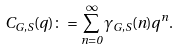<formula> <loc_0><loc_0><loc_500><loc_500>C _ { G , S } ( q ) \colon = \sum _ { n = 0 } ^ { \infty } \gamma _ { G , S } ( n ) q ^ { n } .</formula> 